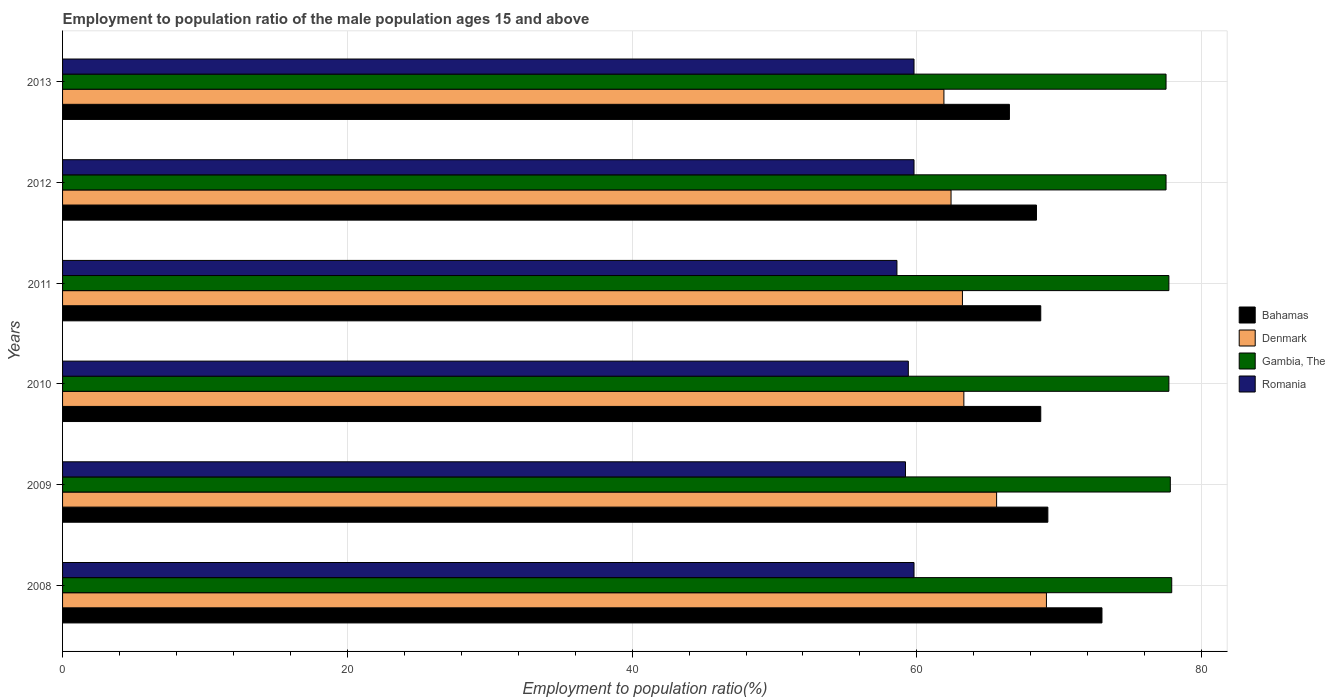How many groups of bars are there?
Keep it short and to the point. 6. Are the number of bars per tick equal to the number of legend labels?
Your answer should be compact. Yes. In how many cases, is the number of bars for a given year not equal to the number of legend labels?
Give a very brief answer. 0. What is the employment to population ratio in Romania in 2013?
Offer a very short reply. 59.8. Across all years, what is the maximum employment to population ratio in Romania?
Your response must be concise. 59.8. Across all years, what is the minimum employment to population ratio in Denmark?
Keep it short and to the point. 61.9. In which year was the employment to population ratio in Bahamas maximum?
Ensure brevity in your answer.  2008. What is the total employment to population ratio in Gambia, The in the graph?
Offer a very short reply. 466.1. What is the difference between the employment to population ratio in Romania in 2008 and that in 2009?
Give a very brief answer. 0.6. What is the difference between the employment to population ratio in Romania in 2009 and the employment to population ratio in Denmark in 2012?
Ensure brevity in your answer.  -3.2. What is the average employment to population ratio in Romania per year?
Your answer should be very brief. 59.43. In the year 2009, what is the difference between the employment to population ratio in Bahamas and employment to population ratio in Romania?
Your response must be concise. 10. What is the ratio of the employment to population ratio in Denmark in 2008 to that in 2011?
Provide a short and direct response. 1.09. Is the employment to population ratio in Bahamas in 2008 less than that in 2013?
Offer a very short reply. No. Is the difference between the employment to population ratio in Bahamas in 2009 and 2010 greater than the difference between the employment to population ratio in Romania in 2009 and 2010?
Provide a succinct answer. Yes. What is the difference between the highest and the lowest employment to population ratio in Romania?
Your answer should be compact. 1.2. Is the sum of the employment to population ratio in Bahamas in 2008 and 2009 greater than the maximum employment to population ratio in Denmark across all years?
Your answer should be compact. Yes. What does the 2nd bar from the top in 2010 represents?
Keep it short and to the point. Gambia, The. What does the 1st bar from the bottom in 2012 represents?
Keep it short and to the point. Bahamas. Is it the case that in every year, the sum of the employment to population ratio in Gambia, The and employment to population ratio in Denmark is greater than the employment to population ratio in Bahamas?
Ensure brevity in your answer.  Yes. How many bars are there?
Keep it short and to the point. 24. Are all the bars in the graph horizontal?
Give a very brief answer. Yes. What is the difference between two consecutive major ticks on the X-axis?
Ensure brevity in your answer.  20. Does the graph contain any zero values?
Make the answer very short. No. Where does the legend appear in the graph?
Your answer should be very brief. Center right. How are the legend labels stacked?
Offer a terse response. Vertical. What is the title of the graph?
Your answer should be compact. Employment to population ratio of the male population ages 15 and above. Does "Ukraine" appear as one of the legend labels in the graph?
Provide a short and direct response. No. What is the label or title of the X-axis?
Offer a very short reply. Employment to population ratio(%). What is the label or title of the Y-axis?
Ensure brevity in your answer.  Years. What is the Employment to population ratio(%) of Denmark in 2008?
Make the answer very short. 69.1. What is the Employment to population ratio(%) of Gambia, The in 2008?
Your answer should be very brief. 77.9. What is the Employment to population ratio(%) of Romania in 2008?
Ensure brevity in your answer.  59.8. What is the Employment to population ratio(%) of Bahamas in 2009?
Offer a very short reply. 69.2. What is the Employment to population ratio(%) in Denmark in 2009?
Ensure brevity in your answer.  65.6. What is the Employment to population ratio(%) in Gambia, The in 2009?
Your answer should be compact. 77.8. What is the Employment to population ratio(%) of Romania in 2009?
Offer a terse response. 59.2. What is the Employment to population ratio(%) in Bahamas in 2010?
Provide a succinct answer. 68.7. What is the Employment to population ratio(%) in Denmark in 2010?
Provide a succinct answer. 63.3. What is the Employment to population ratio(%) of Gambia, The in 2010?
Your answer should be compact. 77.7. What is the Employment to population ratio(%) of Romania in 2010?
Keep it short and to the point. 59.4. What is the Employment to population ratio(%) of Bahamas in 2011?
Provide a succinct answer. 68.7. What is the Employment to population ratio(%) in Denmark in 2011?
Give a very brief answer. 63.2. What is the Employment to population ratio(%) in Gambia, The in 2011?
Ensure brevity in your answer.  77.7. What is the Employment to population ratio(%) of Romania in 2011?
Ensure brevity in your answer.  58.6. What is the Employment to population ratio(%) in Bahamas in 2012?
Your answer should be compact. 68.4. What is the Employment to population ratio(%) in Denmark in 2012?
Make the answer very short. 62.4. What is the Employment to population ratio(%) of Gambia, The in 2012?
Provide a short and direct response. 77.5. What is the Employment to population ratio(%) of Romania in 2012?
Offer a very short reply. 59.8. What is the Employment to population ratio(%) of Bahamas in 2013?
Give a very brief answer. 66.5. What is the Employment to population ratio(%) in Denmark in 2013?
Your answer should be very brief. 61.9. What is the Employment to population ratio(%) in Gambia, The in 2013?
Keep it short and to the point. 77.5. What is the Employment to population ratio(%) in Romania in 2013?
Provide a short and direct response. 59.8. Across all years, what is the maximum Employment to population ratio(%) in Denmark?
Your answer should be compact. 69.1. Across all years, what is the maximum Employment to population ratio(%) of Gambia, The?
Your response must be concise. 77.9. Across all years, what is the maximum Employment to population ratio(%) in Romania?
Provide a succinct answer. 59.8. Across all years, what is the minimum Employment to population ratio(%) of Bahamas?
Ensure brevity in your answer.  66.5. Across all years, what is the minimum Employment to population ratio(%) of Denmark?
Your answer should be very brief. 61.9. Across all years, what is the minimum Employment to population ratio(%) in Gambia, The?
Offer a very short reply. 77.5. Across all years, what is the minimum Employment to population ratio(%) in Romania?
Ensure brevity in your answer.  58.6. What is the total Employment to population ratio(%) of Bahamas in the graph?
Provide a succinct answer. 414.5. What is the total Employment to population ratio(%) in Denmark in the graph?
Provide a short and direct response. 385.5. What is the total Employment to population ratio(%) of Gambia, The in the graph?
Your answer should be compact. 466.1. What is the total Employment to population ratio(%) in Romania in the graph?
Your answer should be very brief. 356.6. What is the difference between the Employment to population ratio(%) in Denmark in 2008 and that in 2009?
Ensure brevity in your answer.  3.5. What is the difference between the Employment to population ratio(%) of Gambia, The in 2008 and that in 2009?
Your response must be concise. 0.1. What is the difference between the Employment to population ratio(%) in Denmark in 2008 and that in 2010?
Ensure brevity in your answer.  5.8. What is the difference between the Employment to population ratio(%) of Gambia, The in 2008 and that in 2010?
Your answer should be compact. 0.2. What is the difference between the Employment to population ratio(%) of Romania in 2008 and that in 2010?
Your response must be concise. 0.4. What is the difference between the Employment to population ratio(%) of Denmark in 2008 and that in 2011?
Provide a short and direct response. 5.9. What is the difference between the Employment to population ratio(%) of Bahamas in 2008 and that in 2012?
Give a very brief answer. 4.6. What is the difference between the Employment to population ratio(%) of Denmark in 2008 and that in 2012?
Give a very brief answer. 6.7. What is the difference between the Employment to population ratio(%) in Romania in 2008 and that in 2012?
Offer a very short reply. 0. What is the difference between the Employment to population ratio(%) in Bahamas in 2008 and that in 2013?
Give a very brief answer. 6.5. What is the difference between the Employment to population ratio(%) in Romania in 2008 and that in 2013?
Your response must be concise. 0. What is the difference between the Employment to population ratio(%) in Bahamas in 2009 and that in 2010?
Offer a terse response. 0.5. What is the difference between the Employment to population ratio(%) of Denmark in 2009 and that in 2010?
Your response must be concise. 2.3. What is the difference between the Employment to population ratio(%) of Gambia, The in 2009 and that in 2010?
Your response must be concise. 0.1. What is the difference between the Employment to population ratio(%) in Romania in 2009 and that in 2010?
Provide a short and direct response. -0.2. What is the difference between the Employment to population ratio(%) in Bahamas in 2009 and that in 2011?
Your answer should be compact. 0.5. What is the difference between the Employment to population ratio(%) of Bahamas in 2009 and that in 2012?
Provide a short and direct response. 0.8. What is the difference between the Employment to population ratio(%) of Gambia, The in 2009 and that in 2012?
Give a very brief answer. 0.3. What is the difference between the Employment to population ratio(%) in Romania in 2009 and that in 2012?
Your response must be concise. -0.6. What is the difference between the Employment to population ratio(%) of Bahamas in 2010 and that in 2011?
Keep it short and to the point. 0. What is the difference between the Employment to population ratio(%) in Denmark in 2010 and that in 2011?
Your response must be concise. 0.1. What is the difference between the Employment to population ratio(%) of Gambia, The in 2010 and that in 2012?
Provide a succinct answer. 0.2. What is the difference between the Employment to population ratio(%) in Romania in 2010 and that in 2012?
Provide a short and direct response. -0.4. What is the difference between the Employment to population ratio(%) of Bahamas in 2010 and that in 2013?
Your answer should be very brief. 2.2. What is the difference between the Employment to population ratio(%) of Denmark in 2010 and that in 2013?
Make the answer very short. 1.4. What is the difference between the Employment to population ratio(%) in Romania in 2010 and that in 2013?
Your answer should be compact. -0.4. What is the difference between the Employment to population ratio(%) in Gambia, The in 2011 and that in 2012?
Offer a very short reply. 0.2. What is the difference between the Employment to population ratio(%) of Romania in 2011 and that in 2012?
Offer a very short reply. -1.2. What is the difference between the Employment to population ratio(%) in Denmark in 2012 and that in 2013?
Offer a terse response. 0.5. What is the difference between the Employment to population ratio(%) of Gambia, The in 2012 and that in 2013?
Your response must be concise. 0. What is the difference between the Employment to population ratio(%) of Romania in 2012 and that in 2013?
Ensure brevity in your answer.  0. What is the difference between the Employment to population ratio(%) in Bahamas in 2008 and the Employment to population ratio(%) in Gambia, The in 2009?
Provide a short and direct response. -4.8. What is the difference between the Employment to population ratio(%) in Bahamas in 2008 and the Employment to population ratio(%) in Romania in 2009?
Provide a short and direct response. 13.8. What is the difference between the Employment to population ratio(%) of Denmark in 2008 and the Employment to population ratio(%) of Gambia, The in 2009?
Provide a short and direct response. -8.7. What is the difference between the Employment to population ratio(%) of Denmark in 2008 and the Employment to population ratio(%) of Romania in 2009?
Provide a succinct answer. 9.9. What is the difference between the Employment to population ratio(%) of Denmark in 2008 and the Employment to population ratio(%) of Gambia, The in 2010?
Provide a short and direct response. -8.6. What is the difference between the Employment to population ratio(%) of Gambia, The in 2008 and the Employment to population ratio(%) of Romania in 2010?
Your answer should be compact. 18.5. What is the difference between the Employment to population ratio(%) of Bahamas in 2008 and the Employment to population ratio(%) of Gambia, The in 2011?
Keep it short and to the point. -4.7. What is the difference between the Employment to population ratio(%) in Denmark in 2008 and the Employment to population ratio(%) in Romania in 2011?
Your answer should be compact. 10.5. What is the difference between the Employment to population ratio(%) in Gambia, The in 2008 and the Employment to population ratio(%) in Romania in 2011?
Your answer should be compact. 19.3. What is the difference between the Employment to population ratio(%) of Bahamas in 2008 and the Employment to population ratio(%) of Gambia, The in 2012?
Give a very brief answer. -4.5. What is the difference between the Employment to population ratio(%) of Bahamas in 2008 and the Employment to population ratio(%) of Romania in 2012?
Your response must be concise. 13.2. What is the difference between the Employment to population ratio(%) of Denmark in 2008 and the Employment to population ratio(%) of Gambia, The in 2012?
Provide a succinct answer. -8.4. What is the difference between the Employment to population ratio(%) of Denmark in 2008 and the Employment to population ratio(%) of Romania in 2012?
Your answer should be compact. 9.3. What is the difference between the Employment to population ratio(%) of Bahamas in 2008 and the Employment to population ratio(%) of Romania in 2013?
Give a very brief answer. 13.2. What is the difference between the Employment to population ratio(%) in Denmark in 2008 and the Employment to population ratio(%) in Romania in 2013?
Keep it short and to the point. 9.3. What is the difference between the Employment to population ratio(%) of Bahamas in 2009 and the Employment to population ratio(%) of Denmark in 2010?
Give a very brief answer. 5.9. What is the difference between the Employment to population ratio(%) in Bahamas in 2009 and the Employment to population ratio(%) in Gambia, The in 2010?
Ensure brevity in your answer.  -8.5. What is the difference between the Employment to population ratio(%) of Bahamas in 2009 and the Employment to population ratio(%) of Romania in 2010?
Provide a short and direct response. 9.8. What is the difference between the Employment to population ratio(%) of Denmark in 2009 and the Employment to population ratio(%) of Gambia, The in 2010?
Provide a succinct answer. -12.1. What is the difference between the Employment to population ratio(%) in Denmark in 2009 and the Employment to population ratio(%) in Romania in 2010?
Your answer should be very brief. 6.2. What is the difference between the Employment to population ratio(%) of Gambia, The in 2009 and the Employment to population ratio(%) of Romania in 2010?
Your answer should be compact. 18.4. What is the difference between the Employment to population ratio(%) in Bahamas in 2009 and the Employment to population ratio(%) in Denmark in 2011?
Offer a very short reply. 6. What is the difference between the Employment to population ratio(%) of Denmark in 2009 and the Employment to population ratio(%) of Gambia, The in 2011?
Offer a very short reply. -12.1. What is the difference between the Employment to population ratio(%) in Denmark in 2009 and the Employment to population ratio(%) in Romania in 2011?
Give a very brief answer. 7. What is the difference between the Employment to population ratio(%) of Bahamas in 2009 and the Employment to population ratio(%) of Denmark in 2012?
Keep it short and to the point. 6.8. What is the difference between the Employment to population ratio(%) of Denmark in 2009 and the Employment to population ratio(%) of Gambia, The in 2012?
Your answer should be compact. -11.9. What is the difference between the Employment to population ratio(%) of Bahamas in 2009 and the Employment to population ratio(%) of Denmark in 2013?
Offer a very short reply. 7.3. What is the difference between the Employment to population ratio(%) of Bahamas in 2009 and the Employment to population ratio(%) of Gambia, The in 2013?
Offer a very short reply. -8.3. What is the difference between the Employment to population ratio(%) in Bahamas in 2009 and the Employment to population ratio(%) in Romania in 2013?
Provide a short and direct response. 9.4. What is the difference between the Employment to population ratio(%) in Denmark in 2009 and the Employment to population ratio(%) in Romania in 2013?
Provide a short and direct response. 5.8. What is the difference between the Employment to population ratio(%) of Bahamas in 2010 and the Employment to population ratio(%) of Denmark in 2011?
Your answer should be compact. 5.5. What is the difference between the Employment to population ratio(%) of Bahamas in 2010 and the Employment to population ratio(%) of Gambia, The in 2011?
Your response must be concise. -9. What is the difference between the Employment to population ratio(%) in Denmark in 2010 and the Employment to population ratio(%) in Gambia, The in 2011?
Give a very brief answer. -14.4. What is the difference between the Employment to population ratio(%) in Denmark in 2010 and the Employment to population ratio(%) in Romania in 2011?
Make the answer very short. 4.7. What is the difference between the Employment to population ratio(%) in Bahamas in 2010 and the Employment to population ratio(%) in Romania in 2012?
Provide a succinct answer. 8.9. What is the difference between the Employment to population ratio(%) of Denmark in 2010 and the Employment to population ratio(%) of Gambia, The in 2012?
Your answer should be compact. -14.2. What is the difference between the Employment to population ratio(%) in Bahamas in 2010 and the Employment to population ratio(%) in Gambia, The in 2013?
Give a very brief answer. -8.8. What is the difference between the Employment to population ratio(%) in Gambia, The in 2010 and the Employment to population ratio(%) in Romania in 2013?
Offer a terse response. 17.9. What is the difference between the Employment to population ratio(%) of Denmark in 2011 and the Employment to population ratio(%) of Gambia, The in 2012?
Give a very brief answer. -14.3. What is the difference between the Employment to population ratio(%) in Denmark in 2011 and the Employment to population ratio(%) in Romania in 2012?
Offer a terse response. 3.4. What is the difference between the Employment to population ratio(%) in Gambia, The in 2011 and the Employment to population ratio(%) in Romania in 2012?
Keep it short and to the point. 17.9. What is the difference between the Employment to population ratio(%) in Bahamas in 2011 and the Employment to population ratio(%) in Denmark in 2013?
Provide a succinct answer. 6.8. What is the difference between the Employment to population ratio(%) of Bahamas in 2011 and the Employment to population ratio(%) of Romania in 2013?
Offer a terse response. 8.9. What is the difference between the Employment to population ratio(%) of Denmark in 2011 and the Employment to population ratio(%) of Gambia, The in 2013?
Make the answer very short. -14.3. What is the difference between the Employment to population ratio(%) in Denmark in 2011 and the Employment to population ratio(%) in Romania in 2013?
Give a very brief answer. 3.4. What is the difference between the Employment to population ratio(%) in Gambia, The in 2011 and the Employment to population ratio(%) in Romania in 2013?
Offer a terse response. 17.9. What is the difference between the Employment to population ratio(%) of Bahamas in 2012 and the Employment to population ratio(%) of Denmark in 2013?
Provide a short and direct response. 6.5. What is the difference between the Employment to population ratio(%) in Bahamas in 2012 and the Employment to population ratio(%) in Romania in 2013?
Ensure brevity in your answer.  8.6. What is the difference between the Employment to population ratio(%) in Denmark in 2012 and the Employment to population ratio(%) in Gambia, The in 2013?
Ensure brevity in your answer.  -15.1. What is the difference between the Employment to population ratio(%) of Denmark in 2012 and the Employment to population ratio(%) of Romania in 2013?
Your answer should be compact. 2.6. What is the difference between the Employment to population ratio(%) of Gambia, The in 2012 and the Employment to population ratio(%) of Romania in 2013?
Your response must be concise. 17.7. What is the average Employment to population ratio(%) of Bahamas per year?
Your answer should be very brief. 69.08. What is the average Employment to population ratio(%) in Denmark per year?
Keep it short and to the point. 64.25. What is the average Employment to population ratio(%) of Gambia, The per year?
Your response must be concise. 77.68. What is the average Employment to population ratio(%) of Romania per year?
Offer a terse response. 59.43. In the year 2008, what is the difference between the Employment to population ratio(%) in Bahamas and Employment to population ratio(%) in Gambia, The?
Provide a short and direct response. -4.9. In the year 2008, what is the difference between the Employment to population ratio(%) of Denmark and Employment to population ratio(%) of Gambia, The?
Make the answer very short. -8.8. In the year 2008, what is the difference between the Employment to population ratio(%) in Gambia, The and Employment to population ratio(%) in Romania?
Your answer should be very brief. 18.1. In the year 2009, what is the difference between the Employment to population ratio(%) of Bahamas and Employment to population ratio(%) of Gambia, The?
Provide a short and direct response. -8.6. In the year 2009, what is the difference between the Employment to population ratio(%) in Denmark and Employment to population ratio(%) in Romania?
Your answer should be compact. 6.4. In the year 2009, what is the difference between the Employment to population ratio(%) in Gambia, The and Employment to population ratio(%) in Romania?
Ensure brevity in your answer.  18.6. In the year 2010, what is the difference between the Employment to population ratio(%) in Bahamas and Employment to population ratio(%) in Romania?
Provide a short and direct response. 9.3. In the year 2010, what is the difference between the Employment to population ratio(%) in Denmark and Employment to population ratio(%) in Gambia, The?
Give a very brief answer. -14.4. In the year 2010, what is the difference between the Employment to population ratio(%) of Gambia, The and Employment to population ratio(%) of Romania?
Offer a very short reply. 18.3. In the year 2011, what is the difference between the Employment to population ratio(%) of Bahamas and Employment to population ratio(%) of Gambia, The?
Give a very brief answer. -9. In the year 2012, what is the difference between the Employment to population ratio(%) in Bahamas and Employment to population ratio(%) in Gambia, The?
Make the answer very short. -9.1. In the year 2012, what is the difference between the Employment to population ratio(%) of Denmark and Employment to population ratio(%) of Gambia, The?
Your answer should be very brief. -15.1. In the year 2012, what is the difference between the Employment to population ratio(%) of Gambia, The and Employment to population ratio(%) of Romania?
Your response must be concise. 17.7. In the year 2013, what is the difference between the Employment to population ratio(%) of Bahamas and Employment to population ratio(%) of Denmark?
Your answer should be compact. 4.6. In the year 2013, what is the difference between the Employment to population ratio(%) in Denmark and Employment to population ratio(%) in Gambia, The?
Ensure brevity in your answer.  -15.6. In the year 2013, what is the difference between the Employment to population ratio(%) in Denmark and Employment to population ratio(%) in Romania?
Ensure brevity in your answer.  2.1. What is the ratio of the Employment to population ratio(%) in Bahamas in 2008 to that in 2009?
Your answer should be compact. 1.05. What is the ratio of the Employment to population ratio(%) of Denmark in 2008 to that in 2009?
Provide a succinct answer. 1.05. What is the ratio of the Employment to population ratio(%) in Romania in 2008 to that in 2009?
Keep it short and to the point. 1.01. What is the ratio of the Employment to population ratio(%) in Bahamas in 2008 to that in 2010?
Provide a short and direct response. 1.06. What is the ratio of the Employment to population ratio(%) in Denmark in 2008 to that in 2010?
Provide a succinct answer. 1.09. What is the ratio of the Employment to population ratio(%) of Bahamas in 2008 to that in 2011?
Ensure brevity in your answer.  1.06. What is the ratio of the Employment to population ratio(%) of Denmark in 2008 to that in 2011?
Give a very brief answer. 1.09. What is the ratio of the Employment to population ratio(%) in Gambia, The in 2008 to that in 2011?
Your answer should be compact. 1. What is the ratio of the Employment to population ratio(%) of Romania in 2008 to that in 2011?
Your answer should be compact. 1.02. What is the ratio of the Employment to population ratio(%) of Bahamas in 2008 to that in 2012?
Your response must be concise. 1.07. What is the ratio of the Employment to population ratio(%) of Denmark in 2008 to that in 2012?
Ensure brevity in your answer.  1.11. What is the ratio of the Employment to population ratio(%) of Romania in 2008 to that in 2012?
Make the answer very short. 1. What is the ratio of the Employment to population ratio(%) of Bahamas in 2008 to that in 2013?
Offer a terse response. 1.1. What is the ratio of the Employment to population ratio(%) of Denmark in 2008 to that in 2013?
Keep it short and to the point. 1.12. What is the ratio of the Employment to population ratio(%) in Gambia, The in 2008 to that in 2013?
Keep it short and to the point. 1.01. What is the ratio of the Employment to population ratio(%) in Romania in 2008 to that in 2013?
Give a very brief answer. 1. What is the ratio of the Employment to population ratio(%) of Bahamas in 2009 to that in 2010?
Ensure brevity in your answer.  1.01. What is the ratio of the Employment to population ratio(%) in Denmark in 2009 to that in 2010?
Make the answer very short. 1.04. What is the ratio of the Employment to population ratio(%) in Gambia, The in 2009 to that in 2010?
Provide a succinct answer. 1. What is the ratio of the Employment to population ratio(%) in Romania in 2009 to that in 2010?
Offer a very short reply. 1. What is the ratio of the Employment to population ratio(%) of Bahamas in 2009 to that in 2011?
Provide a succinct answer. 1.01. What is the ratio of the Employment to population ratio(%) of Denmark in 2009 to that in 2011?
Your response must be concise. 1.04. What is the ratio of the Employment to population ratio(%) in Gambia, The in 2009 to that in 2011?
Offer a terse response. 1. What is the ratio of the Employment to population ratio(%) of Romania in 2009 to that in 2011?
Your response must be concise. 1.01. What is the ratio of the Employment to population ratio(%) in Bahamas in 2009 to that in 2012?
Your response must be concise. 1.01. What is the ratio of the Employment to population ratio(%) in Denmark in 2009 to that in 2012?
Offer a terse response. 1.05. What is the ratio of the Employment to population ratio(%) in Bahamas in 2009 to that in 2013?
Your answer should be compact. 1.04. What is the ratio of the Employment to population ratio(%) of Denmark in 2009 to that in 2013?
Offer a terse response. 1.06. What is the ratio of the Employment to population ratio(%) in Romania in 2009 to that in 2013?
Provide a short and direct response. 0.99. What is the ratio of the Employment to population ratio(%) in Romania in 2010 to that in 2011?
Make the answer very short. 1.01. What is the ratio of the Employment to population ratio(%) of Denmark in 2010 to that in 2012?
Give a very brief answer. 1.01. What is the ratio of the Employment to population ratio(%) of Gambia, The in 2010 to that in 2012?
Ensure brevity in your answer.  1. What is the ratio of the Employment to population ratio(%) in Bahamas in 2010 to that in 2013?
Your response must be concise. 1.03. What is the ratio of the Employment to population ratio(%) of Denmark in 2010 to that in 2013?
Your answer should be compact. 1.02. What is the ratio of the Employment to population ratio(%) of Gambia, The in 2010 to that in 2013?
Your answer should be very brief. 1. What is the ratio of the Employment to population ratio(%) in Romania in 2010 to that in 2013?
Give a very brief answer. 0.99. What is the ratio of the Employment to population ratio(%) of Denmark in 2011 to that in 2012?
Provide a short and direct response. 1.01. What is the ratio of the Employment to population ratio(%) in Romania in 2011 to that in 2012?
Provide a succinct answer. 0.98. What is the ratio of the Employment to population ratio(%) in Bahamas in 2011 to that in 2013?
Give a very brief answer. 1.03. What is the ratio of the Employment to population ratio(%) of Romania in 2011 to that in 2013?
Provide a succinct answer. 0.98. What is the ratio of the Employment to population ratio(%) in Bahamas in 2012 to that in 2013?
Offer a very short reply. 1.03. What is the ratio of the Employment to population ratio(%) of Denmark in 2012 to that in 2013?
Make the answer very short. 1.01. What is the ratio of the Employment to population ratio(%) in Gambia, The in 2012 to that in 2013?
Provide a succinct answer. 1. What is the ratio of the Employment to population ratio(%) of Romania in 2012 to that in 2013?
Your answer should be compact. 1. What is the difference between the highest and the second highest Employment to population ratio(%) of Bahamas?
Your response must be concise. 3.8. What is the difference between the highest and the second highest Employment to population ratio(%) of Denmark?
Your answer should be very brief. 3.5. What is the difference between the highest and the lowest Employment to population ratio(%) of Denmark?
Your answer should be compact. 7.2. 